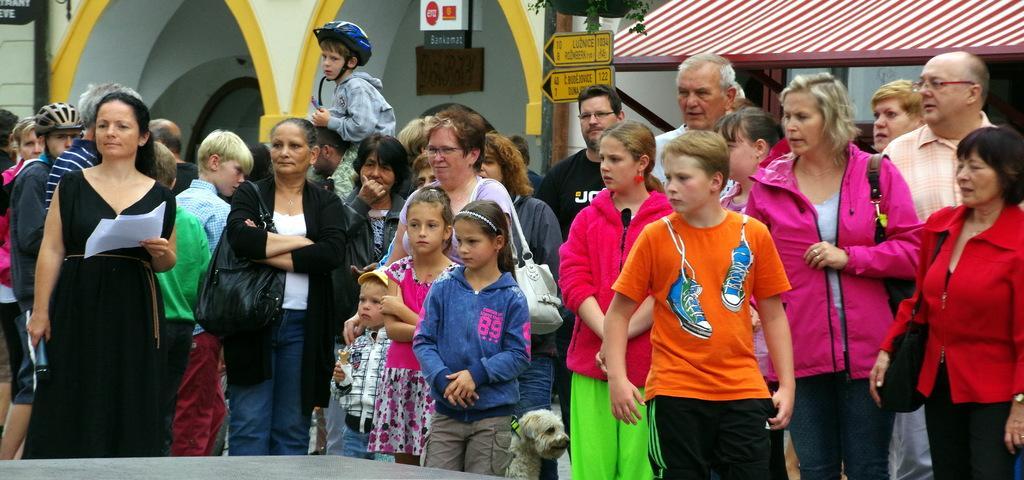In one or two sentences, can you explain what this image depicts? In this image we can see men women, boys and girls are standing. Behind them one shelter is present and one building is there. In the middle of the image one girl is standing, she is wearing blue color top with grey pant. Beside her one dog is there. Right side of the image one lady is standing, she is wearing red color coat with black pant and carrying black bag. Left side of the image one woman is standing, she is wearing black dress and holding mic in one hand and papers in the other hand. 